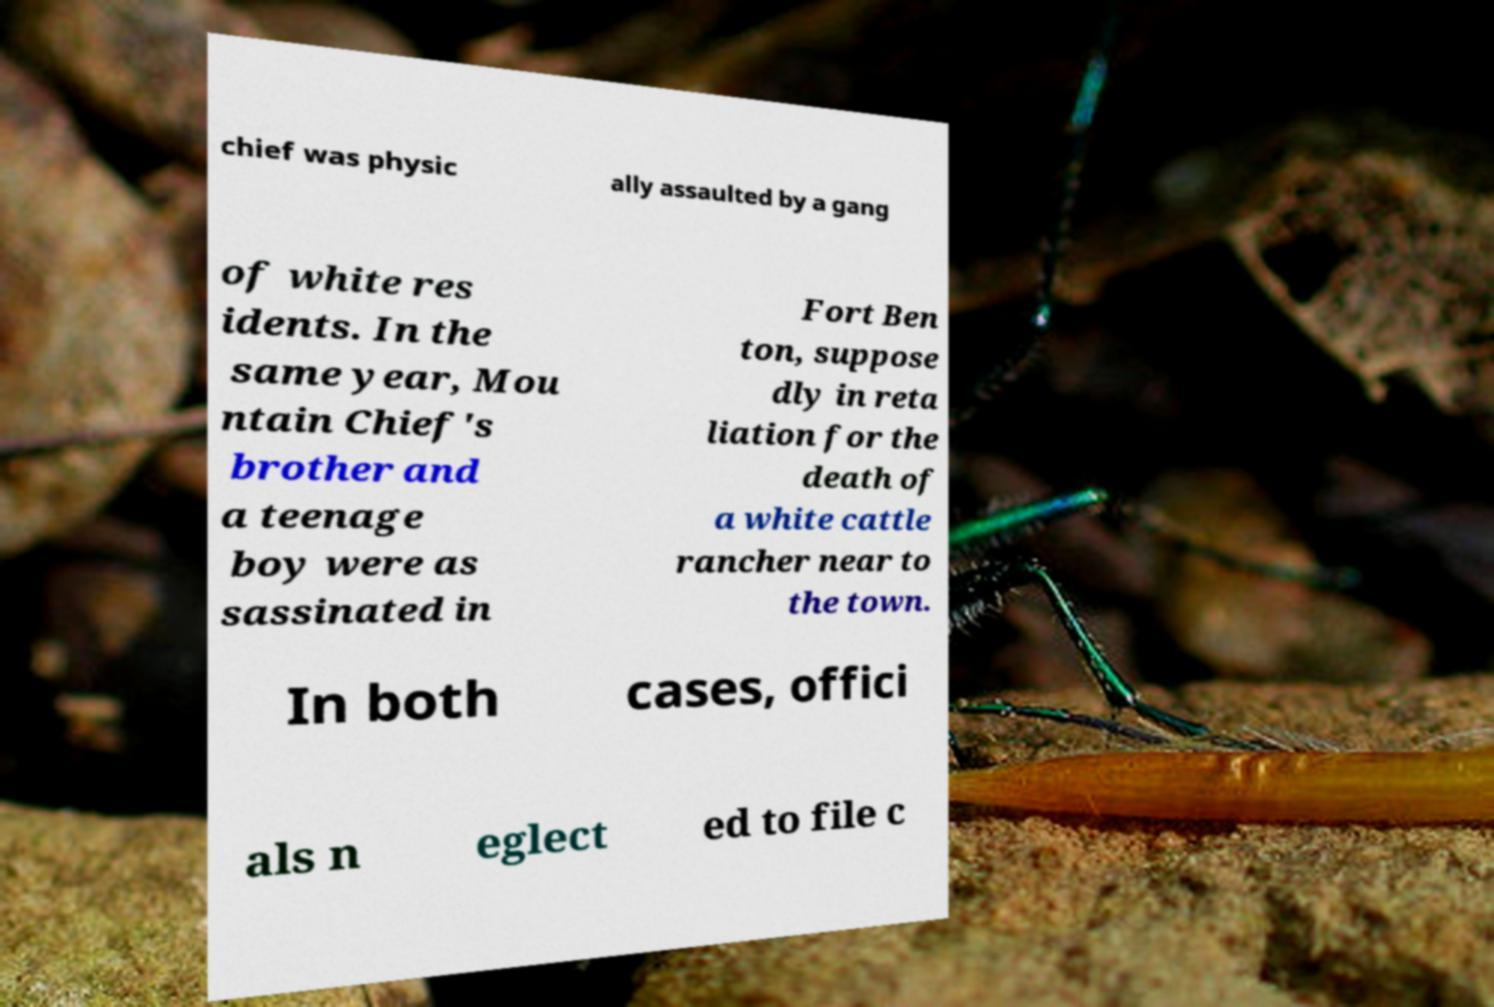Please read and relay the text visible in this image. What does it say? chief was physic ally assaulted by a gang of white res idents. In the same year, Mou ntain Chief's brother and a teenage boy were as sassinated in Fort Ben ton, suppose dly in reta liation for the death of a white cattle rancher near to the town. In both cases, offici als n eglect ed to file c 